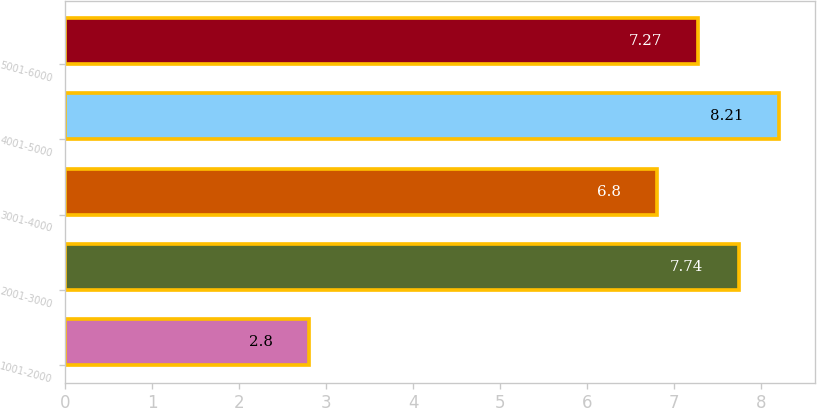Convert chart. <chart><loc_0><loc_0><loc_500><loc_500><bar_chart><fcel>1001-2000<fcel>2001-3000<fcel>3001-4000<fcel>4001-5000<fcel>5001-6000<nl><fcel>2.8<fcel>7.74<fcel>6.8<fcel>8.21<fcel>7.27<nl></chart> 